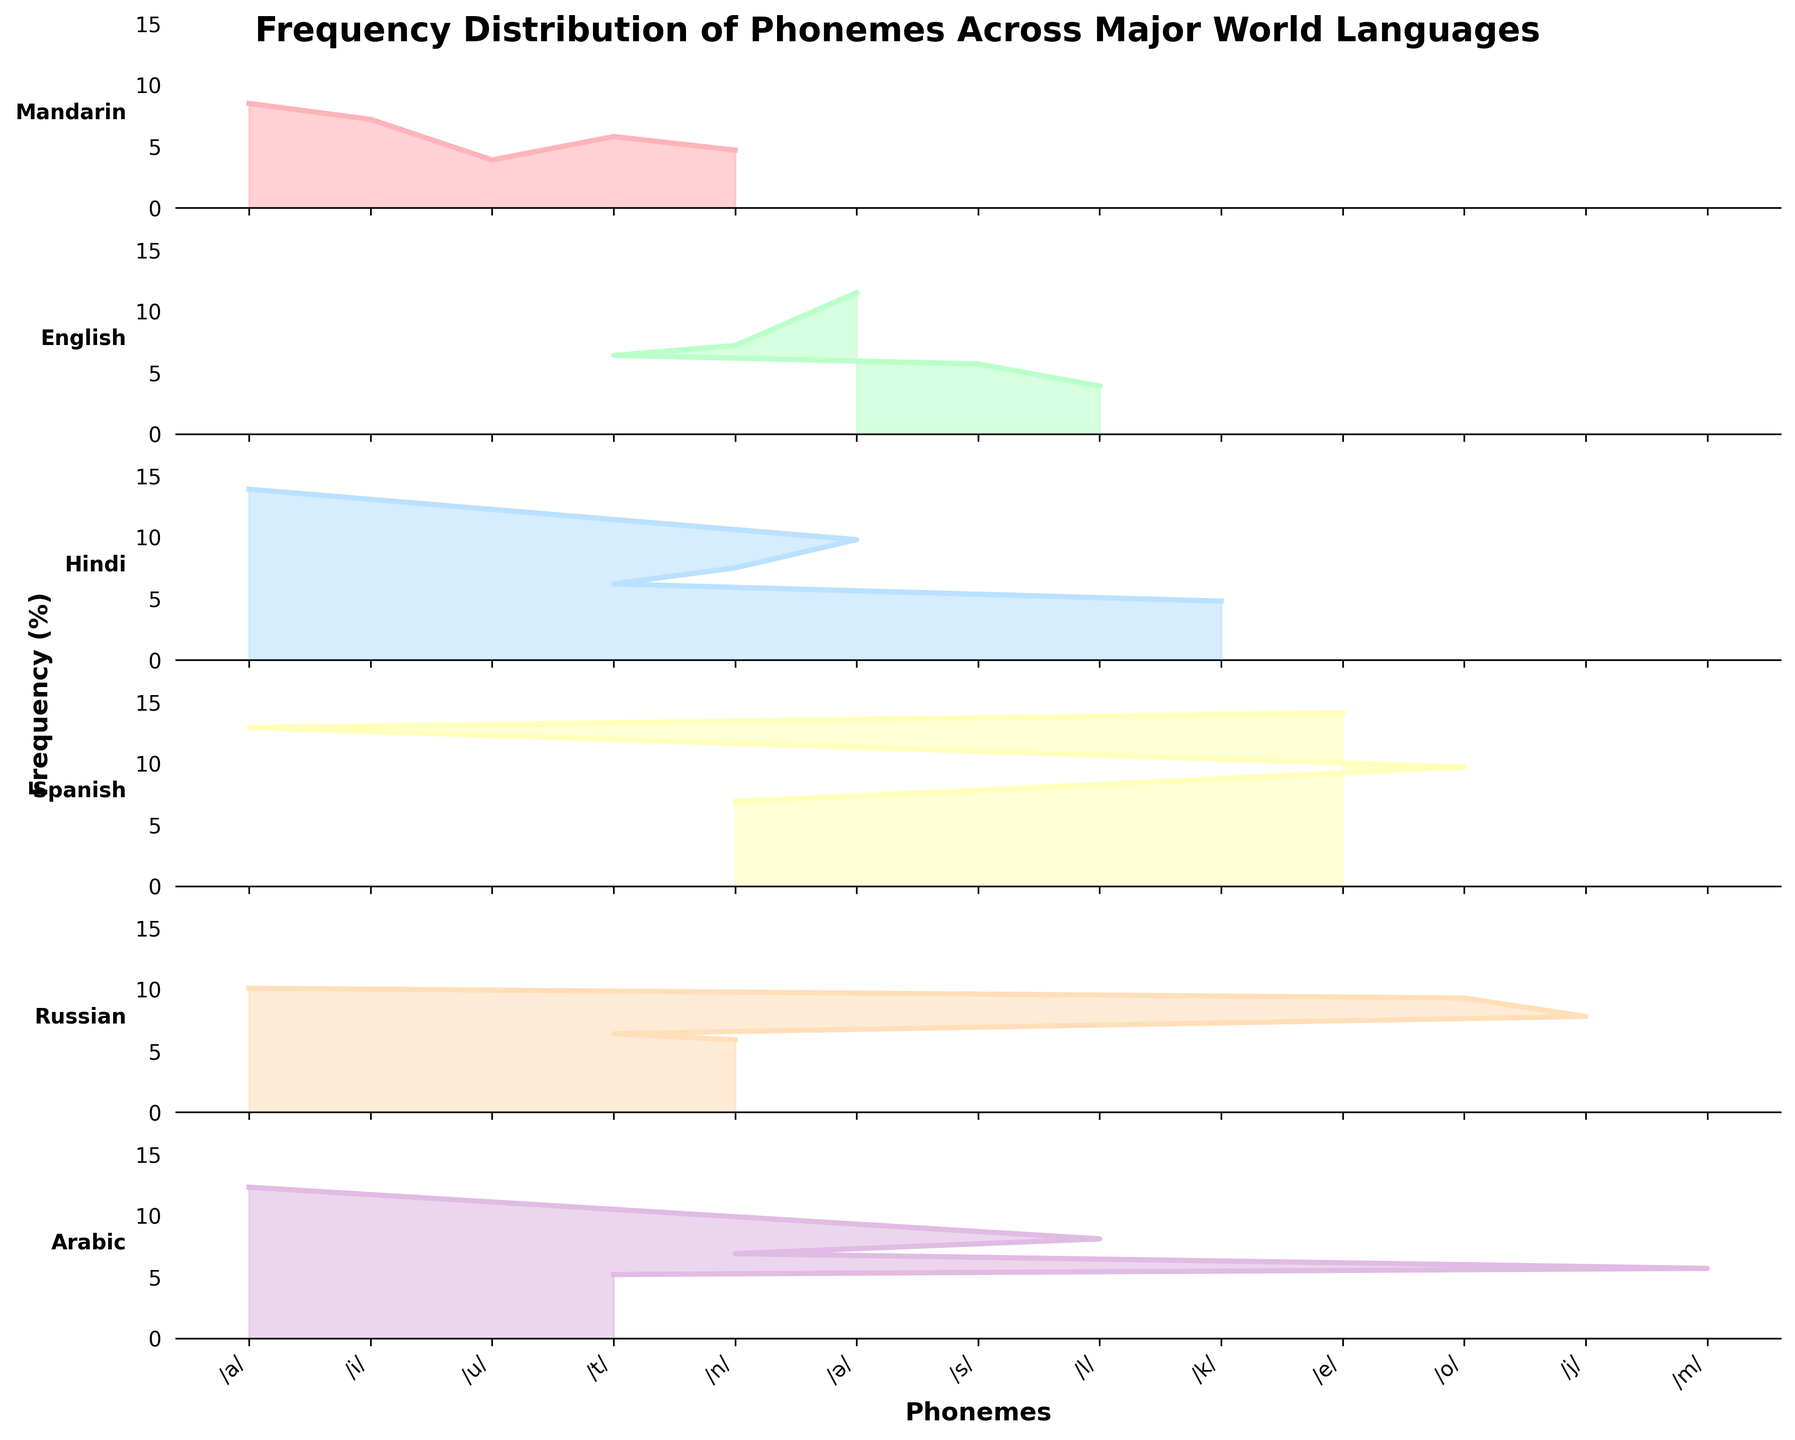what is the most frequent phoneme in English? Look at the section for English in the plot, find the phoneme with the highest peak
Answer: /ə/ which language has the highest peak for the phoneme /a/? Observing the plot, compare the peak frequencies of /a/ among all languages
Answer: Hindi how does the frequency distribution of /t/ compare between Arabic and Russian? Check the sections for Arabic and Russian and compare the heights of the peaks for the phoneme /t/
Answer: Russian has a higher peak for /t/ than Arabic which phonemes are common between English and Mandarin? Identify the phonemes in English and Mandarin sections and find common ones
Answer: /n/ and /t/ what's the average frequency of the phoneme /n/ across all languages? Calculate the sum of the frequencies of /n/ in each language and divide by the number of languages; (4.7+7.2+7.5+6.9+5.9+6.9)/6 = 6.52
Answer: 6.52 are there any languages where /ə/ has the highest frequency peak compared to other phonemes within the same language? Check if /ə/ is the highest peak within any language section
Answer: English if you combine the phonemes /a/, /ə/, and /n/, which language has the highest total frequency? Sum the frequencies of /a/, /ə/, and /n/ in each language and find the highest sum; Mandarin: 8.5+0+4.7, English: 0+11.5+7.2, Hindi: 13.9+9.8+7.5, Spanish: 12.9+0+6.9, Russian: 10.1+0+5.9, Arabic: 12.3+0+6.9. The highest sum is Hindi with 31.2
Answer: Hindi what is the least frequent phoneme in Spanish? Check the section for Spanish and find the phoneme with the lowest peak
Answer: /n/ which language has the most equal distribution of phoneme frequencies? Compare the overall shape and fluctuations of peaks within each language section to identify a language where peaks are more uniform
Answer: Spanish what phoneme does Russian have that is not present in any other language? Identify the unique phoneme peaks in the Russian section that are not found in any other language sections
Answer: /j/ 